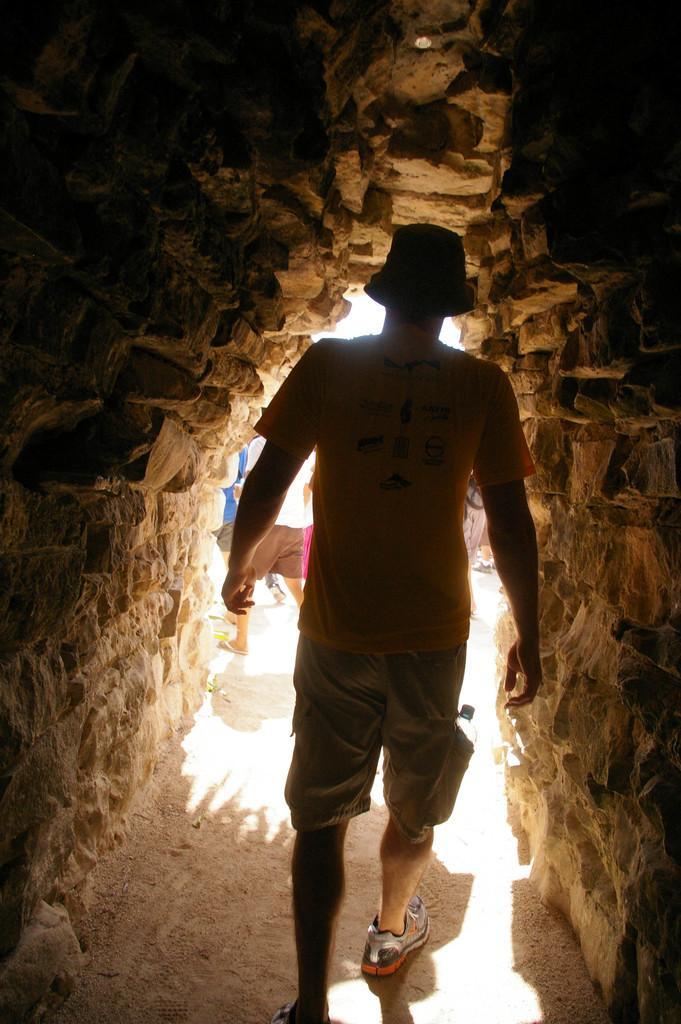What is happening in the foreground of the image? There is a man walking in the foreground of the image. Where is the man located? The man is in a cave-like structure. What is happening in the background of the image? There are persons moving in the background of the image. How are the persons in the background positioned? The persons are on the ground. How many cent frames are hanging on the wall in the image? There is no mention of cent frames or walls in the image; it features a man walking in a cave-like structure and persons moving on the ground in the background. What type of basin can be seen in the image? There is no basin present in the image. 